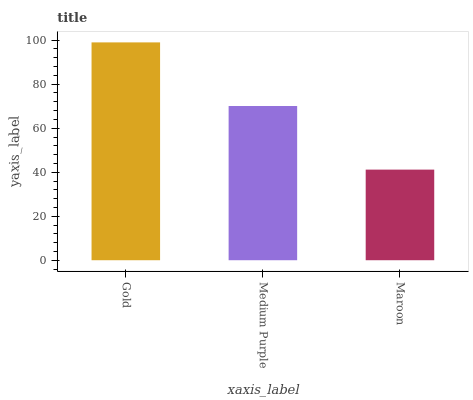Is Maroon the minimum?
Answer yes or no. Yes. Is Gold the maximum?
Answer yes or no. Yes. Is Medium Purple the minimum?
Answer yes or no. No. Is Medium Purple the maximum?
Answer yes or no. No. Is Gold greater than Medium Purple?
Answer yes or no. Yes. Is Medium Purple less than Gold?
Answer yes or no. Yes. Is Medium Purple greater than Gold?
Answer yes or no. No. Is Gold less than Medium Purple?
Answer yes or no. No. Is Medium Purple the high median?
Answer yes or no. Yes. Is Medium Purple the low median?
Answer yes or no. Yes. Is Gold the high median?
Answer yes or no. No. Is Maroon the low median?
Answer yes or no. No. 